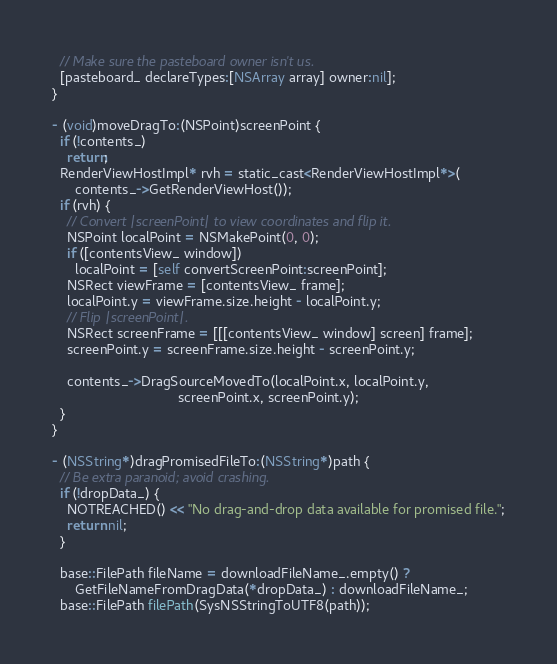<code> <loc_0><loc_0><loc_500><loc_500><_ObjectiveC_>  // Make sure the pasteboard owner isn't us.
  [pasteboard_ declareTypes:[NSArray array] owner:nil];
}

- (void)moveDragTo:(NSPoint)screenPoint {
  if (!contents_)
    return;
  RenderViewHostImpl* rvh = static_cast<RenderViewHostImpl*>(
      contents_->GetRenderViewHost());
  if (rvh) {
    // Convert |screenPoint| to view coordinates and flip it.
    NSPoint localPoint = NSMakePoint(0, 0);
    if ([contentsView_ window])
      localPoint = [self convertScreenPoint:screenPoint];
    NSRect viewFrame = [contentsView_ frame];
    localPoint.y = viewFrame.size.height - localPoint.y;
    // Flip |screenPoint|.
    NSRect screenFrame = [[[contentsView_ window] screen] frame];
    screenPoint.y = screenFrame.size.height - screenPoint.y;

    contents_->DragSourceMovedTo(localPoint.x, localPoint.y,
                                 screenPoint.x, screenPoint.y);
  }
}

- (NSString*)dragPromisedFileTo:(NSString*)path {
  // Be extra paranoid; avoid crashing.
  if (!dropData_) {
    NOTREACHED() << "No drag-and-drop data available for promised file.";
    return nil;
  }

  base::FilePath fileName = downloadFileName_.empty() ?
      GetFileNameFromDragData(*dropData_) : downloadFileName_;
  base::FilePath filePath(SysNSStringToUTF8(path));</code> 